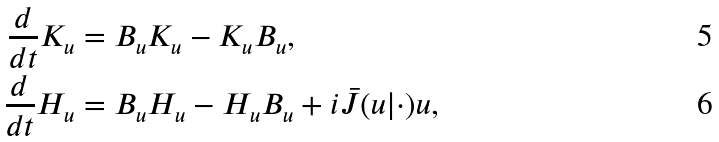<formula> <loc_0><loc_0><loc_500><loc_500>\frac { d } { d t } K _ { u } & = B _ { u } K _ { u } - K _ { u } B _ { u } , \\ \frac { d } { d t } H _ { u } & = B _ { u } H _ { u } - H _ { u } B _ { u } + i \bar { J } ( u | \cdot ) u ,</formula> 